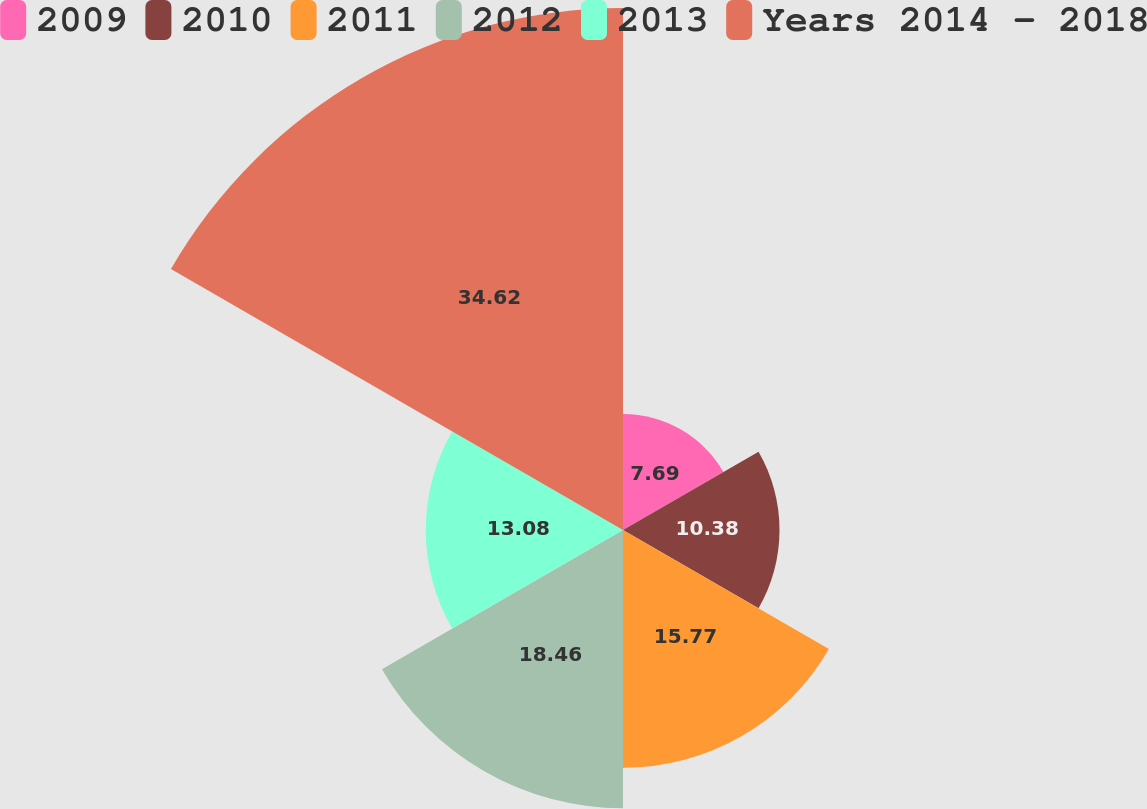Convert chart. <chart><loc_0><loc_0><loc_500><loc_500><pie_chart><fcel>2009<fcel>2010<fcel>2011<fcel>2012<fcel>2013<fcel>Years 2014 - 2018<nl><fcel>7.69%<fcel>10.38%<fcel>15.77%<fcel>18.46%<fcel>13.08%<fcel>34.62%<nl></chart> 